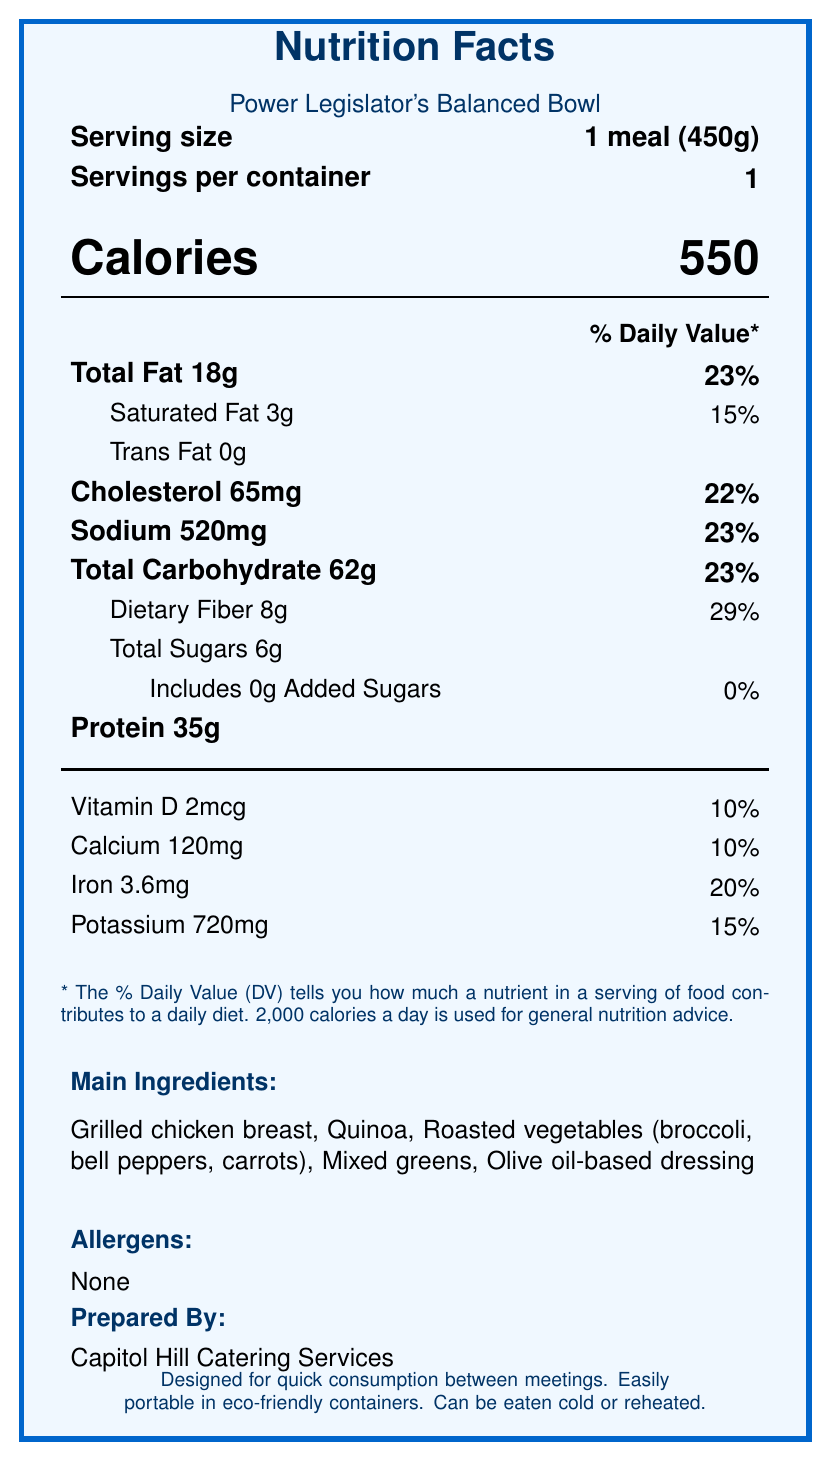what is the serving size? The serving size is listed as "1 meal (450g)" near the top of the document under "Serving size".
Answer: 1 meal (450g) what are the main ingredients of the Power Legislator's Balanced Bowl? The main ingredients are detailed under the "Main Ingredients" section of the document.
Answer: Grilled chicken breast, Quinoa, Roasted vegetables (broccoli, bell peppers, carrots), Mixed greens, Olive oil-based dressing how many calories does the Power Legislator's Balanced Bowl contain? The calorie information is prominently displayed in the middle of the document with the text "Calories" followed by "550".
Answer: 550 calories what is the percentage of daily value for dietary fiber? The percentage of daily value for dietary fiber is listed as 29% under the "Dietary Fiber" row in the macronutrient section.
Answer: 29% how much protein is in one serving of this meal? The protein content is listed as "Protein 35g" in the macronutrient section.
Answer: 35g what is the sodium content in one serving? The sodium content is listed as "Sodium 520mg" in the macronutrient section.
Answer: 520mg how much vitamin D does this meal provide? The vitamin D content is listed as "Vitamin D 2mcg" in the micronutrient section.
Answer: 2mcg who prepared the Power Legislator's Balanced Bowl? The meal was prepared by Capitol Hill Catering Services, as stated near the bottom of the document.
Answer: Capitol Hill Catering Services what features make this meal suitable for busy lawmakers? The special features section highlights that the meal is designed for quick consumption, portability, and flexibility in temperature.
Answer: Designed for quick consumption between meetings, easily portable in eco-friendly containers, can be eaten cold or reheated what is the amount of added sugars in this meal? The amount of added sugars is clearly stated as "0g" under the "Includes 0g Added Sugars" line in the macronutrient section.
Answer: 0g which of the following nutrients has the highest percentage of daily value in this meal? 
A. Total Fat 
B. Cholesterol 
C. Dietary Fiber 
D. Iron The document lists the following daily values: Total Fat 23%, Cholesterol 22%, Dietary Fiber 29%, and Iron 20%. Dietary Fiber has the highest at 29%.
Answer: C. Dietary Fiber where are the ingredients for this meal sourced from? 
1. Local farms in Virginia and Maryland
2. International suppliers
3. California farms
4. Neighboring states The sustainability information at the end of the document states that ingredients are sourced from local farms in Virginia and Maryland.
Answer: 1. Local farms in Virginia and Maryland is this meal free from common allergens? Under the "Allergens" section, it is stated that there are none.
Answer: Yes summarize the main idea of the document. The summary involves describing key aspects like nutritional content, ingredients, preparation, special features, and sustainability information, which are all provided in the document.
Answer: The document provides detailed nutritional information, ingredients, and preparation notes for the Power Legislator's Balanced Bowl, a healthy meal designed for busy politicians. It includes macronutrient and micronutrient breakdowns, serving size, calorie content, and special features such as quick consumption and portability, with ingredients sourced from local farms. what is the main purpose of consulting the Office of the Attending Physician in the meal development? The document mentions that the meal plan was developed in consultation with the Office of the Attending Physician, but it does not specify the main purpose of this consultation.
Answer: Cannot be determined 